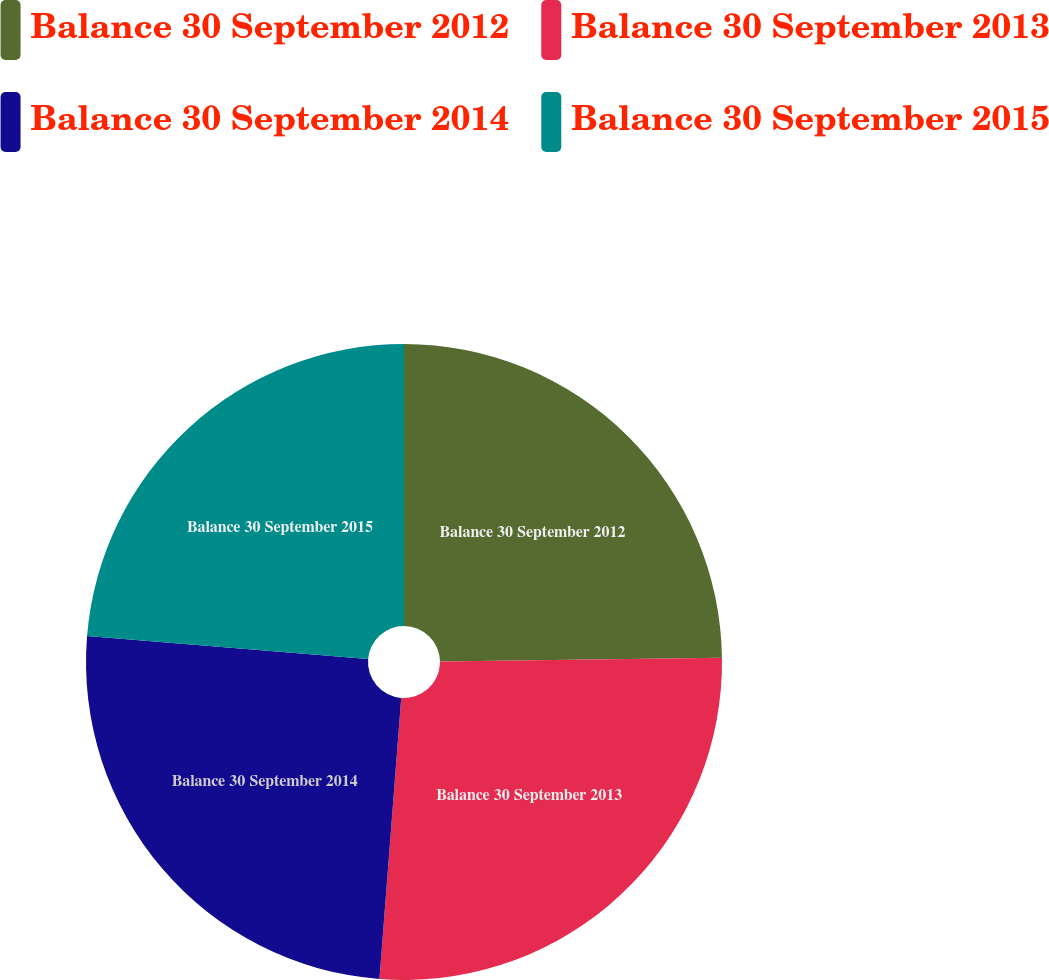Convert chart to OTSL. <chart><loc_0><loc_0><loc_500><loc_500><pie_chart><fcel>Balance 30 September 2012<fcel>Balance 30 September 2013<fcel>Balance 30 September 2014<fcel>Balance 30 September 2015<nl><fcel>24.79%<fcel>26.44%<fcel>25.07%<fcel>23.7%<nl></chart> 